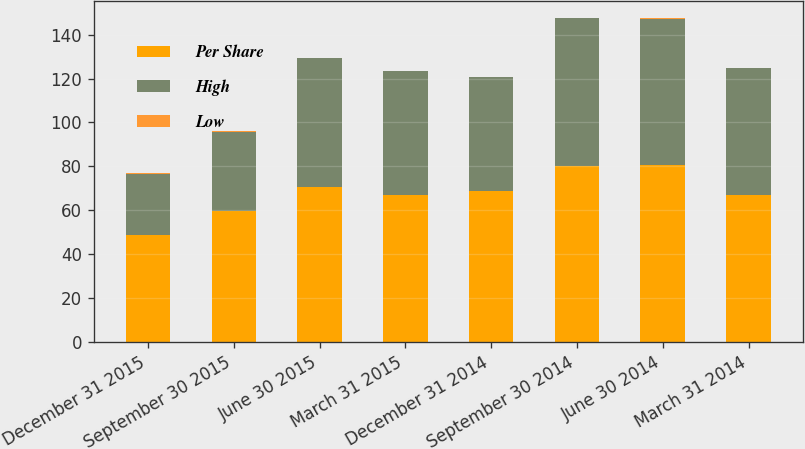Convert chart. <chart><loc_0><loc_0><loc_500><loc_500><stacked_bar_chart><ecel><fcel>December 31 2015<fcel>September 30 2015<fcel>June 30 2015<fcel>March 31 2015<fcel>December 31 2014<fcel>September 30 2014<fcel>June 30 2014<fcel>March 31 2014<nl><fcel>Per Share<fcel>48.68<fcel>59.8<fcel>70.48<fcel>67.08<fcel>68.8<fcel>80.01<fcel>80.63<fcel>66.95<nl><fcel>High<fcel>28<fcel>36.01<fcel>58.77<fcel>56.35<fcel>51.76<fcel>67.58<fcel>66.75<fcel>57.67<nl><fcel>Low<fcel>0.24<fcel>0.24<fcel>0.24<fcel>0.24<fcel>0.24<fcel>0.24<fcel>0.24<fcel>0.22<nl></chart> 